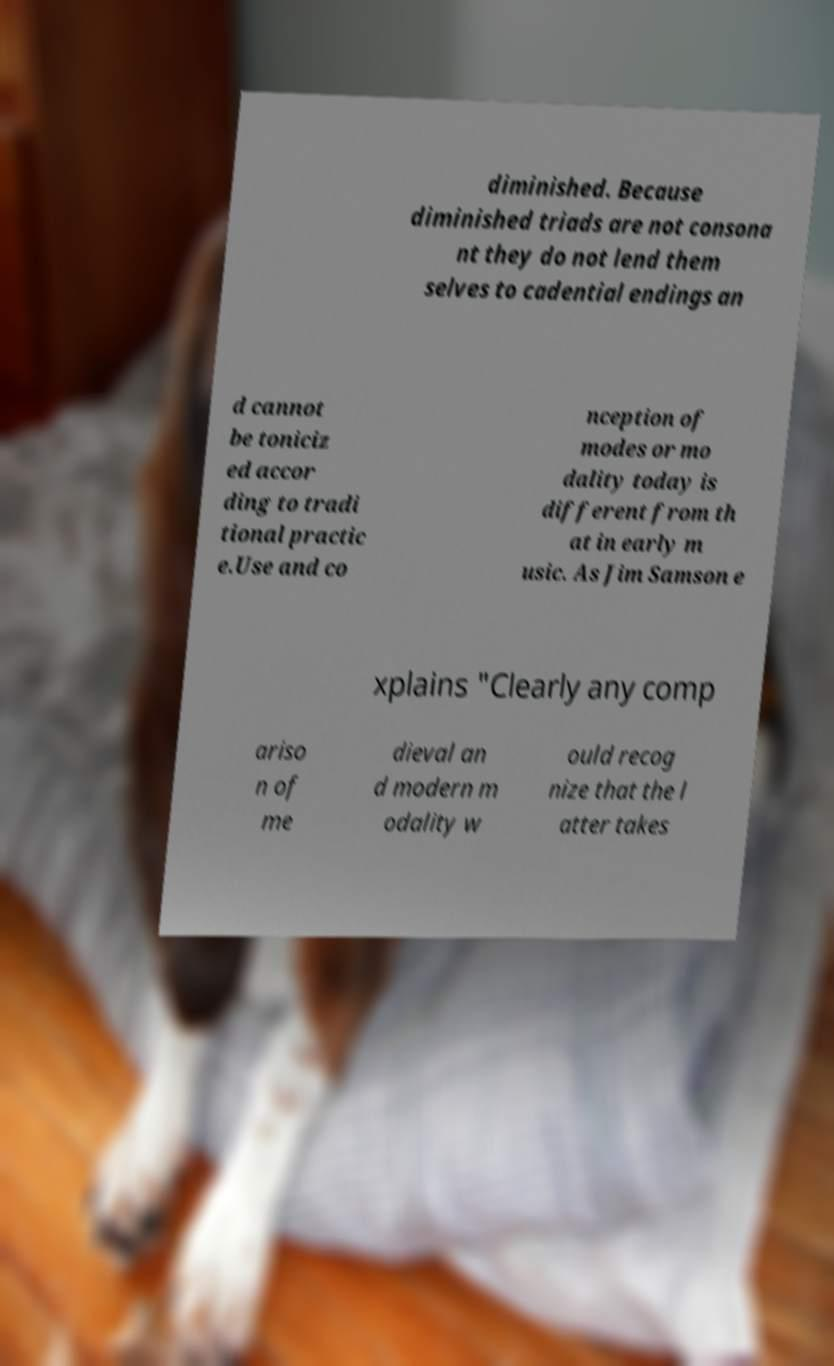Can you read and provide the text displayed in the image?This photo seems to have some interesting text. Can you extract and type it out for me? diminished. Because diminished triads are not consona nt they do not lend them selves to cadential endings an d cannot be toniciz ed accor ding to tradi tional practic e.Use and co nception of modes or mo dality today is different from th at in early m usic. As Jim Samson e xplains "Clearly any comp ariso n of me dieval an d modern m odality w ould recog nize that the l atter takes 